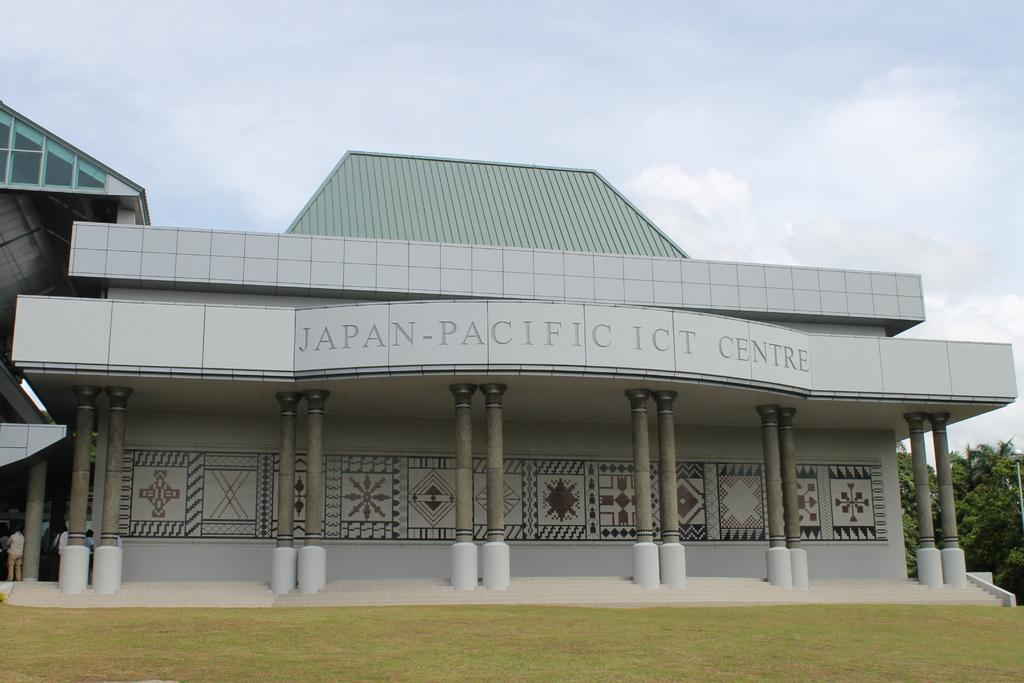What color is the building in the image? The building is grey in color. What can be seen in the middle of the building? The name of the building is visible in the middle. How would you describe the sky in the image? The sky is cloudy in the image. What type of vegetation is on the right side of the image? There are trees on the right side of the image. Where is the flame located in the image? There is no flame present in the image. What type of plate is used to serve the food in the image? There is no food or plate present in the image. 